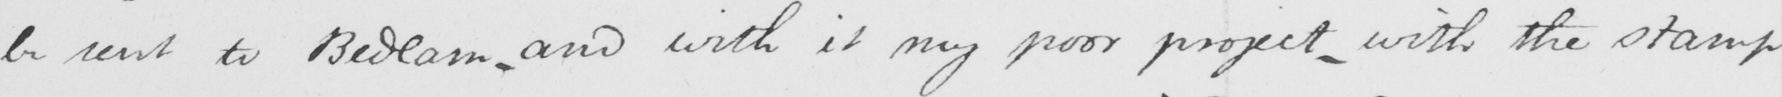What is written in this line of handwriting? be sent to Bedlam , and with it my poor project , with the stamp 